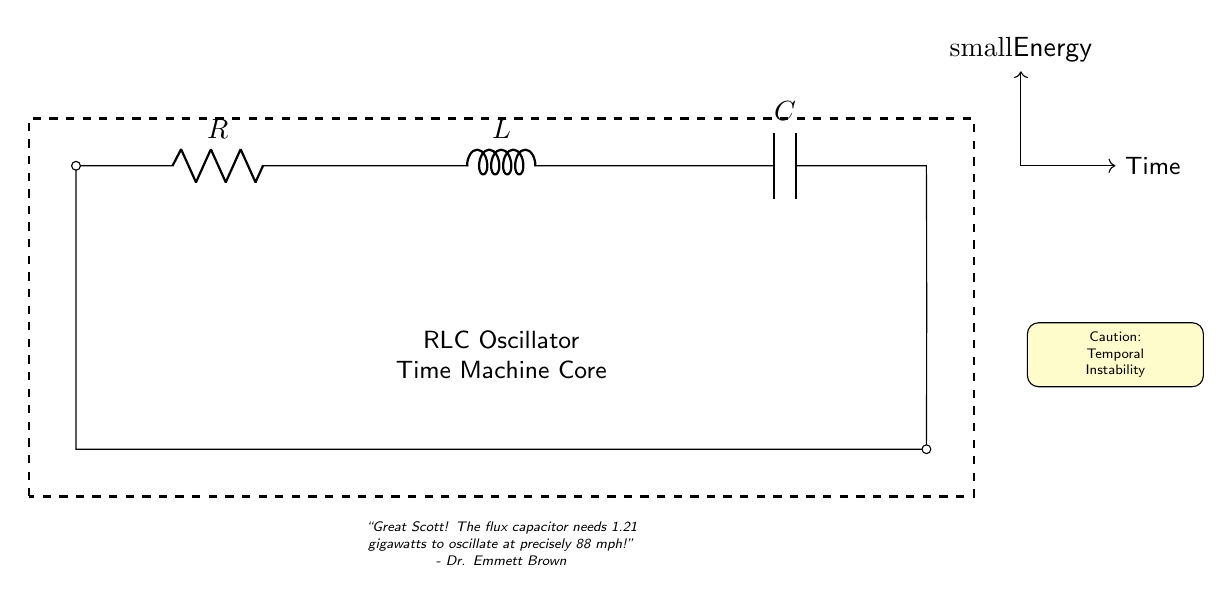What are the components present in this circuit? The circuit diagram includes three key components: a resistor, an inductor, and a capacitor, as indicated by their respective symbols and labels on the diagram.
Answer: Resistor, Inductor, Capacitor What is the labeled value for the inductor in this circuit? The inductor is labeled with the symbol L, which signifies its role in the circuit. The specific value is not provided in the diagram.
Answer: L What type of circuit is shown here? This circuit is an RLC oscillator circuit, which is designed to create oscillations using the combination of the resistor, inductor, and capacitor. The accompanying text reinforces its function as a time machine core.
Answer: RLC oscillator What does the caution note refer to in the context of this circuit? The caution note indicates "Temporal Instability," suggesting that the operation of this circuit in a time machine context may lead to unpredictable outcomes due to the nature of temporal mechanics.
Answer: Temporal Instability How many components are connected in series in this circuit? The resistor, inductor, and capacitor are connected in series, forming a single path for current flow, which is typical for an RLC circuit. There are three main components.
Answer: Three What phrase in the diagram represents a specific power requirement for operation? The quote “1.21 gigawatts” is mentioned in relation to the flux capacitor's need for energy to achieve a specific operational state (88 mph), which is pivotal for the time machine's function.
Answer: 1.21 gigawatts What is the function of the RLC oscillator in the context of the time machine prop? The RLC oscillator creates oscillatory circuits that can resonate at specific frequencies, allowing for the manipulation of time as suggested in science fiction narratives about time travel.
Answer: Time manipulation 